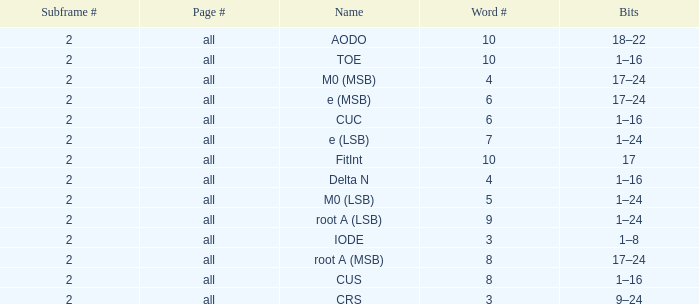What is the average word count with crs and subframes lesser than 2? None. 